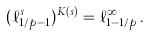Convert formula to latex. <formula><loc_0><loc_0><loc_500><loc_500>( \ell _ { 1 / p - 1 } ^ { s } ) ^ { K ( s ) } = \ell _ { 1 - 1 / p } ^ { \infty } \, .</formula> 